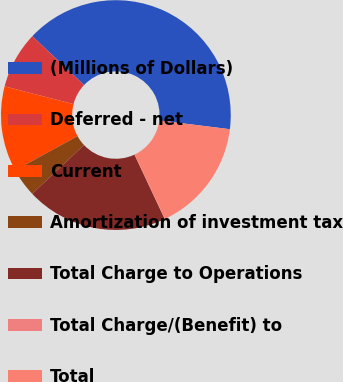<chart> <loc_0><loc_0><loc_500><loc_500><pie_chart><fcel>(Millions of Dollars)<fcel>Deferred - net<fcel>Current<fcel>Amortization of investment tax<fcel>Total Charge to Operations<fcel>Total Charge/(Benefit) to<fcel>Total<nl><fcel>39.93%<fcel>8.02%<fcel>12.01%<fcel>4.03%<fcel>19.98%<fcel>0.04%<fcel>16.0%<nl></chart> 